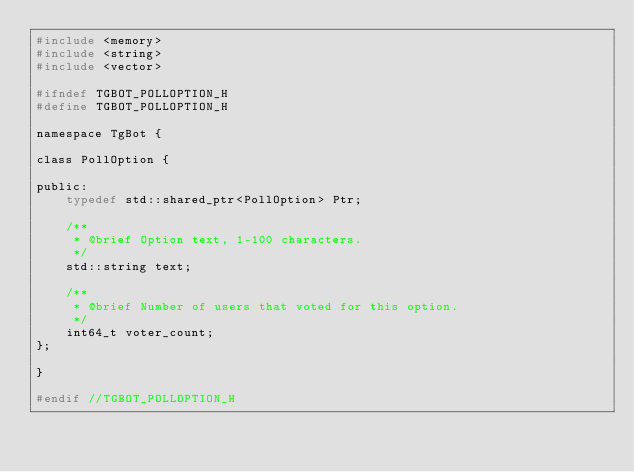<code> <loc_0><loc_0><loc_500><loc_500><_C_>#include <memory>
#include <string>
#include <vector>

#ifndef TGBOT_POLLOPTION_H
#define TGBOT_POLLOPTION_H

namespace TgBot {

class PollOption {

public:
    typedef std::shared_ptr<PollOption> Ptr;

    /**
     * @brief Option text, 1-100 characters.
     */
    std::string text;

    /**
     * @brief Number of users that voted for this option.
     */
    int64_t voter_count;
};

}

#endif //TGBOT_POLLOPTION_H
</code> 